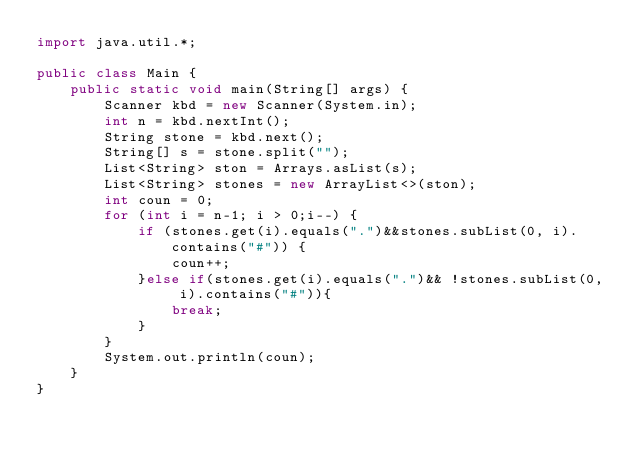<code> <loc_0><loc_0><loc_500><loc_500><_Java_>import java.util.*;

public class Main {
    public static void main(String[] args) {
        Scanner kbd = new Scanner(System.in);
        int n = kbd.nextInt();
        String stone = kbd.next();
        String[] s = stone.split("");
        List<String> ston = Arrays.asList(s);
        List<String> stones = new ArrayList<>(ston);
        int coun = 0;
        for (int i = n-1; i > 0;i--) {
            if (stones.get(i).equals(".")&&stones.subList(0, i).contains("#")) {
                coun++;
            }else if(stones.get(i).equals(".")&& !stones.subList(0, i).contains("#")){
                break;
            } 
        }
        System.out.println(coun);
    }
}</code> 